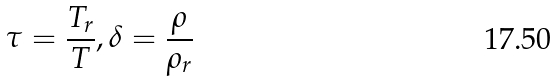Convert formula to latex. <formula><loc_0><loc_0><loc_500><loc_500>\tau = { \frac { T _ { r } } { T } } , \delta = { \frac { \rho } { \rho _ { r } } }</formula> 